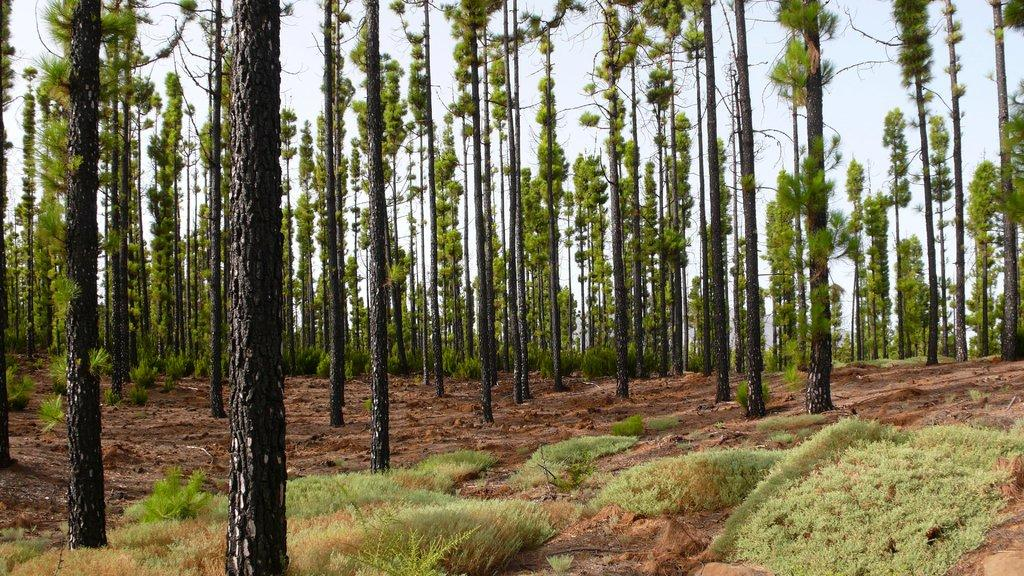What type of vegetation is present in the image? There are many trees in the image. What else can be seen on the ground in the image? There is grass in the image. What is the condition of the sky in the image? The sky is clear in the image. Where is the lake located in the image? There is no lake present in the image; it features trees and grass. What type of flower can be seen growing near the trees in the image? There is no flower present in the image; it only features trees and grass. 